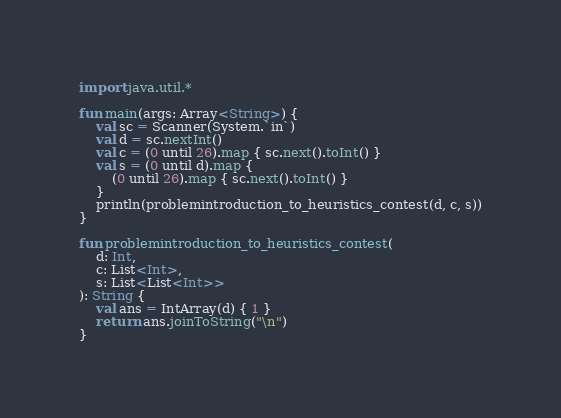Convert code to text. <code><loc_0><loc_0><loc_500><loc_500><_Kotlin_>import java.util.*

fun main(args: Array<String>) {
    val sc = Scanner(System.`in`)
    val d = sc.nextInt()
    val c = (0 until 26).map { sc.next().toInt() }
    val s = (0 until d).map {
        (0 until 26).map { sc.next().toInt() }
    }
    println(problemintroduction_to_heuristics_contest(d, c, s))
}

fun problemintroduction_to_heuristics_contest(
    d: Int,
    c: List<Int>,
    s: List<List<Int>>
): String {
    val ans = IntArray(d) { 1 }
    return ans.joinToString("\n")
}</code> 